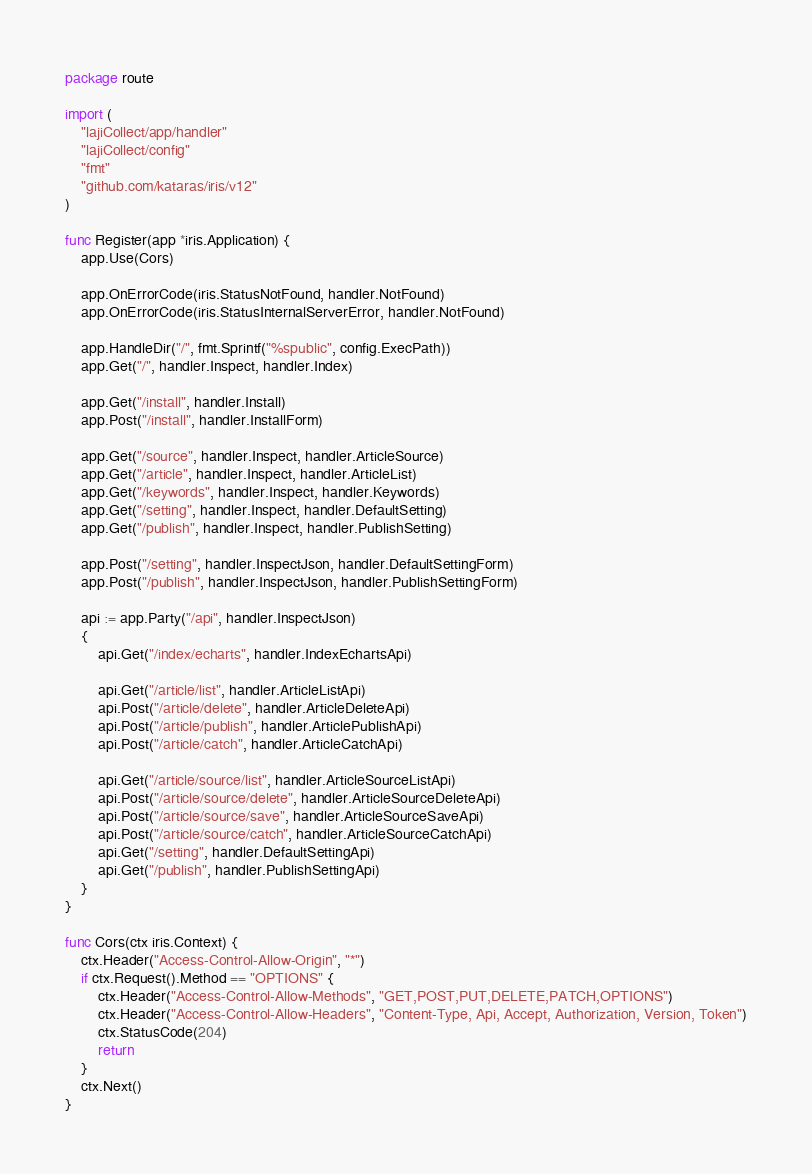<code> <loc_0><loc_0><loc_500><loc_500><_Go_>package route

import (
	"lajiCollect/app/handler"
	"lajiCollect/config"
	"fmt"
	"github.com/kataras/iris/v12"
)

func Register(app *iris.Application) {
	app.Use(Cors)

	app.OnErrorCode(iris.StatusNotFound, handler.NotFound)
	app.OnErrorCode(iris.StatusInternalServerError, handler.NotFound)

	app.HandleDir("/", fmt.Sprintf("%spublic", config.ExecPath))
	app.Get("/", handler.Inspect, handler.Index)

	app.Get("/install", handler.Install)
	app.Post("/install", handler.InstallForm)

	app.Get("/source", handler.Inspect, handler.ArticleSource)
	app.Get("/article", handler.Inspect, handler.ArticleList)
	app.Get("/keywords", handler.Inspect, handler.Keywords)
	app.Get("/setting", handler.Inspect, handler.DefaultSetting)
	app.Get("/publish", handler.Inspect, handler.PublishSetting)

	app.Post("/setting", handler.InspectJson, handler.DefaultSettingForm)
	app.Post("/publish", handler.InspectJson, handler.PublishSettingForm)

	api := app.Party("/api", handler.InspectJson)
	{
		api.Get("/index/echarts", handler.IndexEchartsApi)

		api.Get("/article/list", handler.ArticleListApi)
		api.Post("/article/delete", handler.ArticleDeleteApi)
		api.Post("/article/publish", handler.ArticlePublishApi)
		api.Post("/article/catch", handler.ArticleCatchApi)

		api.Get("/article/source/list", handler.ArticleSourceListApi)
		api.Post("/article/source/delete", handler.ArticleSourceDeleteApi)
		api.Post("/article/source/save", handler.ArticleSourceSaveApi)
		api.Post("/article/source/catch", handler.ArticleSourceCatchApi)
		api.Get("/setting", handler.DefaultSettingApi)
		api.Get("/publish", handler.PublishSettingApi)
	}
}

func Cors(ctx iris.Context) {
	ctx.Header("Access-Control-Allow-Origin", "*")
	if ctx.Request().Method == "OPTIONS" {
		ctx.Header("Access-Control-Allow-Methods", "GET,POST,PUT,DELETE,PATCH,OPTIONS")
		ctx.Header("Access-Control-Allow-Headers", "Content-Type, Api, Accept, Authorization, Version, Token")
		ctx.StatusCode(204)
		return
	}
	ctx.Next()
}
</code> 